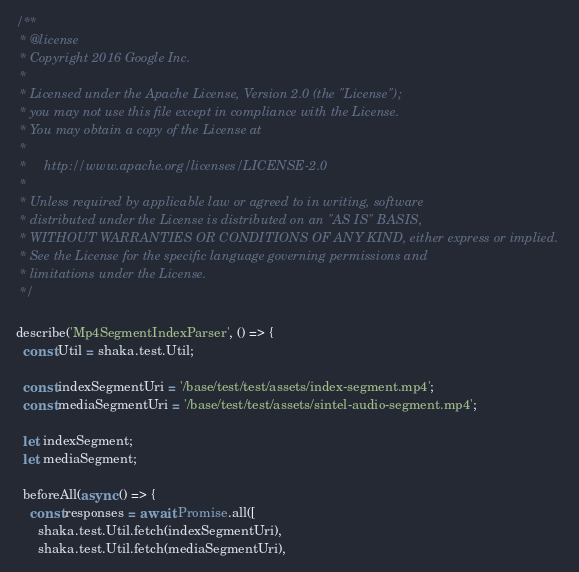<code> <loc_0><loc_0><loc_500><loc_500><_JavaScript_>/**
 * @license
 * Copyright 2016 Google Inc.
 *
 * Licensed under the Apache License, Version 2.0 (the "License");
 * you may not use this file except in compliance with the License.
 * You may obtain a copy of the License at
 *
 *     http://www.apache.org/licenses/LICENSE-2.0
 *
 * Unless required by applicable law or agreed to in writing, software
 * distributed under the License is distributed on an "AS IS" BASIS,
 * WITHOUT WARRANTIES OR CONDITIONS OF ANY KIND, either express or implied.
 * See the License for the specific language governing permissions and
 * limitations under the License.
 */

describe('Mp4SegmentIndexParser', () => {
  const Util = shaka.test.Util;

  const indexSegmentUri = '/base/test/test/assets/index-segment.mp4';
  const mediaSegmentUri = '/base/test/test/assets/sintel-audio-segment.mp4';

  let indexSegment;
  let mediaSegment;

  beforeAll(async () => {
    const responses = await Promise.all([
      shaka.test.Util.fetch(indexSegmentUri),
      shaka.test.Util.fetch(mediaSegmentUri),</code> 